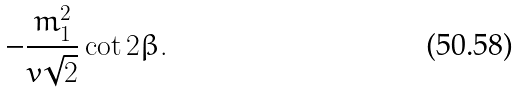Convert formula to latex. <formula><loc_0><loc_0><loc_500><loc_500>- { \frac { m _ { 1 } ^ { 2 } } { v \sqrt { 2 } } } \cot 2 \beta .</formula> 